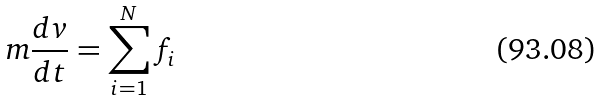Convert formula to latex. <formula><loc_0><loc_0><loc_500><loc_500>m \frac { d v } { d t } = \sum _ { i = 1 } ^ { N } f _ { i }</formula> 